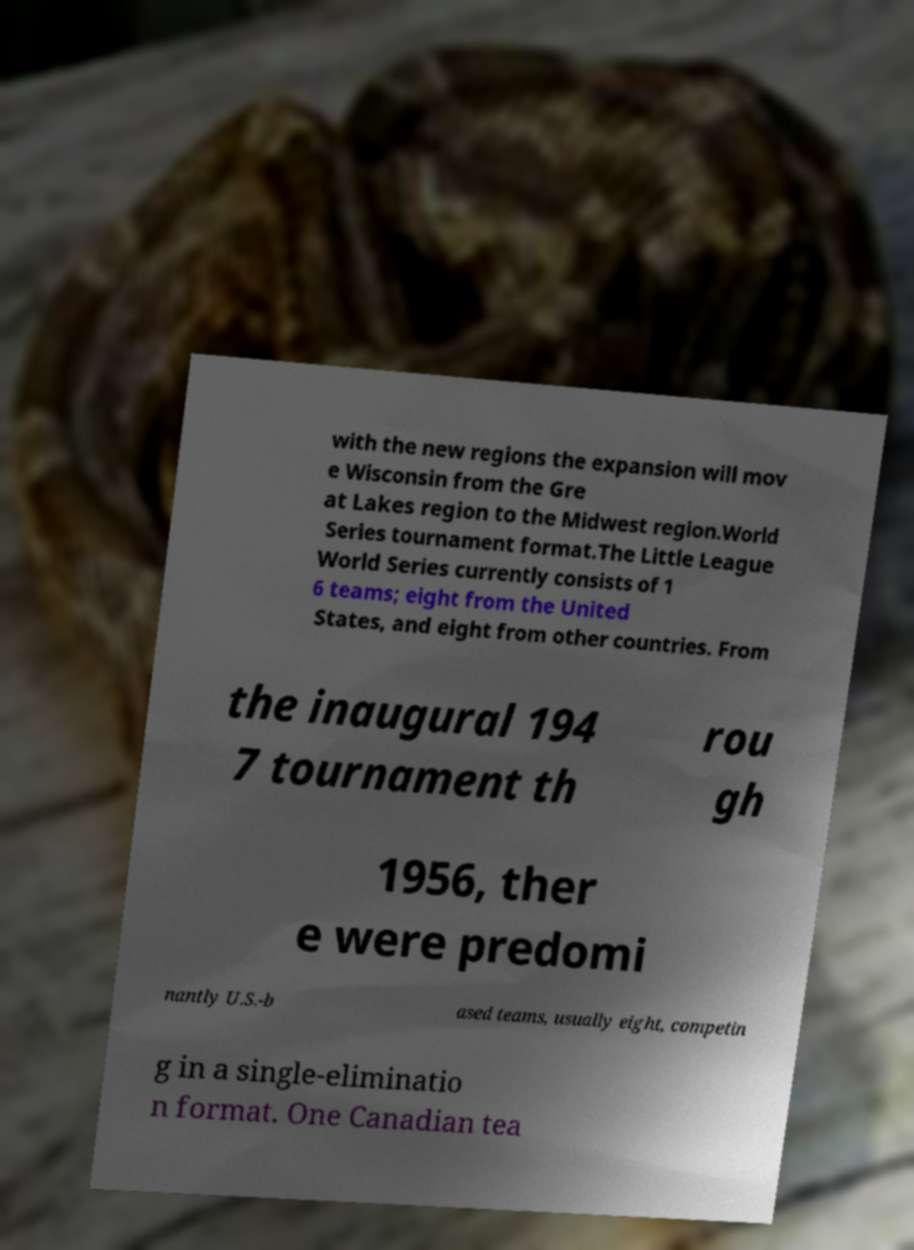Please read and relay the text visible in this image. What does it say? with the new regions the expansion will mov e Wisconsin from the Gre at Lakes region to the Midwest region.World Series tournament format.The Little League World Series currently consists of 1 6 teams; eight from the United States, and eight from other countries. From the inaugural 194 7 tournament th rou gh 1956, ther e were predomi nantly U.S.-b ased teams, usually eight, competin g in a single-eliminatio n format. One Canadian tea 